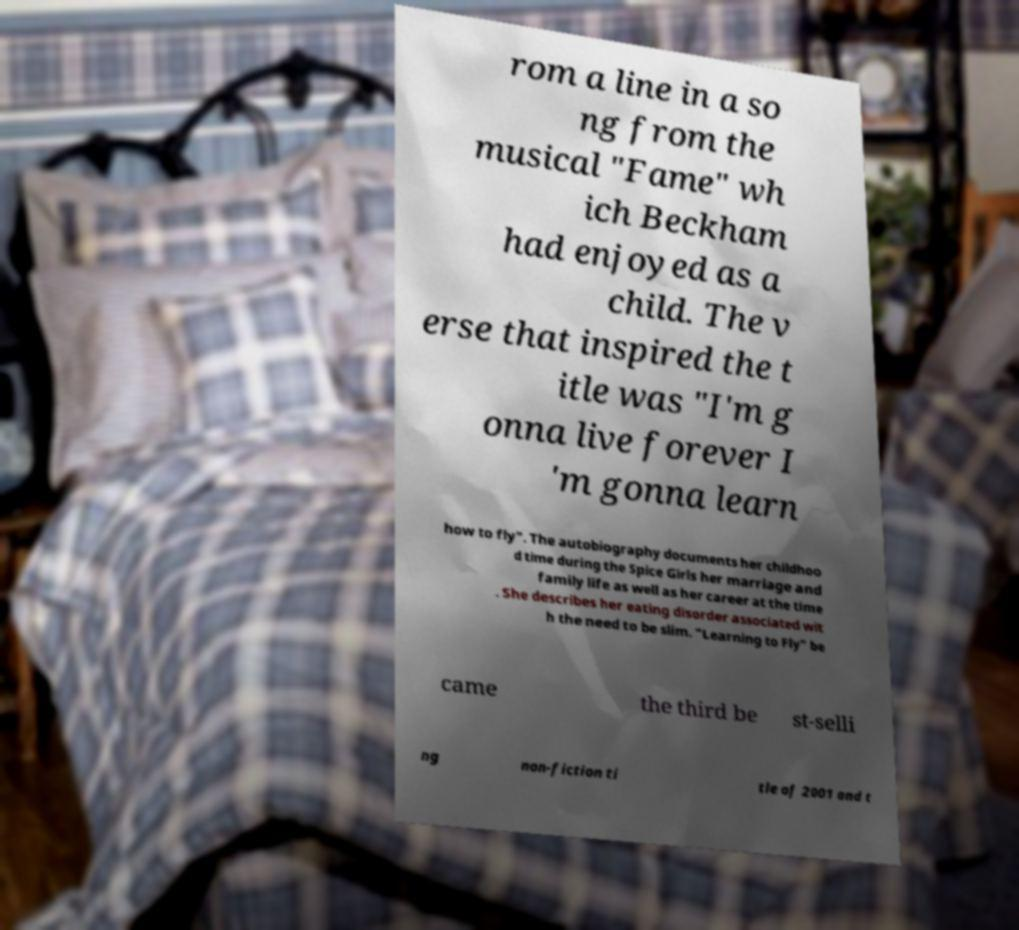Could you assist in decoding the text presented in this image and type it out clearly? rom a line in a so ng from the musical "Fame" wh ich Beckham had enjoyed as a child. The v erse that inspired the t itle was "I'm g onna live forever I 'm gonna learn how to fly". The autobiography documents her childhoo d time during the Spice Girls her marriage and family life as well as her career at the time . She describes her eating disorder associated wit h the need to be slim. "Learning to Fly" be came the third be st-selli ng non-fiction ti tle of 2001 and t 